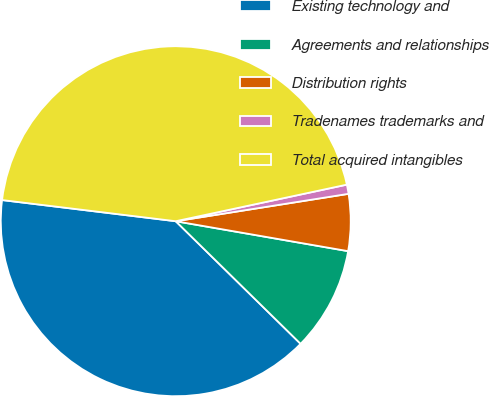Convert chart to OTSL. <chart><loc_0><loc_0><loc_500><loc_500><pie_chart><fcel>Existing technology and<fcel>Agreements and relationships<fcel>Distribution rights<fcel>Tradenames trademarks and<fcel>Total acquired intangibles<nl><fcel>39.58%<fcel>9.62%<fcel>5.24%<fcel>0.85%<fcel>44.72%<nl></chart> 